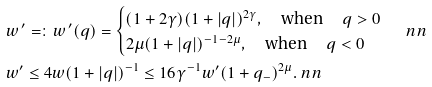<formula> <loc_0><loc_0><loc_500><loc_500>& w ^ { \, \prime } = \colon w ^ { \, \prime } ( q ) = \begin{cases} ( 1 + 2 \gamma ) ( 1 + | q | ) ^ { 2 \gamma } , \quad \text {when } \quad q > 0 \\ 2 \mu ( 1 + | q | ) ^ { - 1 - 2 \mu } , \quad \text {when } \quad q < 0 \end{cases} \ n n \\ & w ^ { \prime } \leq 4 w ( 1 + | q | ) ^ { - 1 } \leq 1 6 \gamma ^ { - 1 } w ^ { \prime } ( 1 + q _ { - } ) ^ { 2 \mu } . \ n n</formula> 